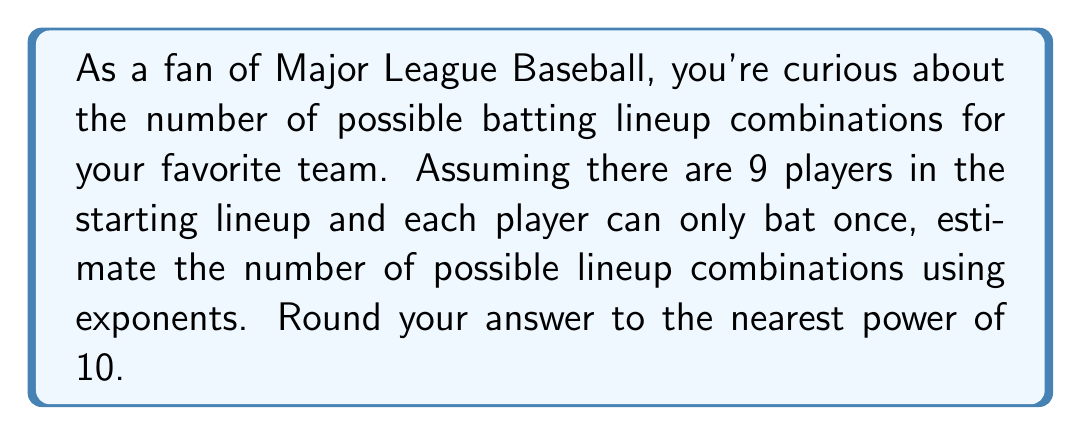Teach me how to tackle this problem. Let's approach this step-by-step:

1) In a baseball lineup, there are 9 positions to fill with 9 players.

2) For the first position, we have 9 choices.

3) For the second position, we have 8 choices remaining, and so on.

4) This scenario follows the principle of permutations, which can be expressed as:

   $9 \times 8 \times 7 \times 6 \times 5 \times 4 \times 3 \times 2 \times 1$

5) This is also known as 9 factorial, written as $9!$

6) We can calculate this:

   $9! = 362,880$

7) To express this using exponents and round to the nearest power of 10, we need to find the closest power of 10 to 362,880.

8) $10^5 = 100,000$ (too small)
   $10^6 = 1,000,000$ (too large)

9) 362,880 is closer to $10^5$ than to $10^6$

Therefore, we can estimate the number of possible lineup combinations as approximately $10^5$.
Answer: $10^5$ 